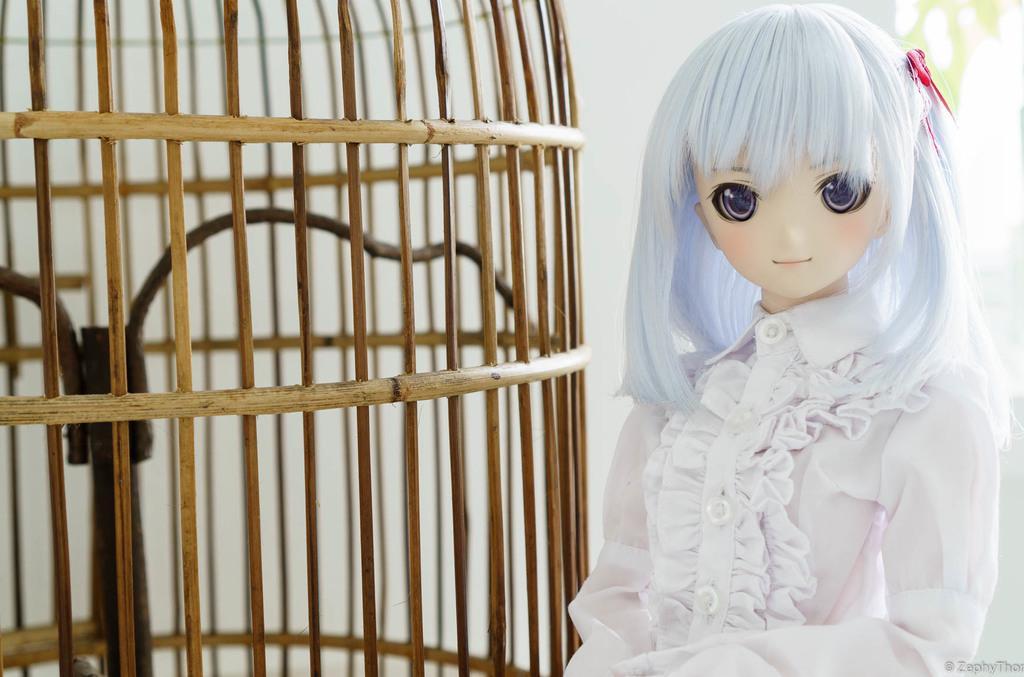Can you describe this image briefly? In the picture we can see a baby girl doll with white color clothes and white hair and pink color clip on it and beside her we can see a bird cage made up of a wooden stick and in the background we can see a wall. 